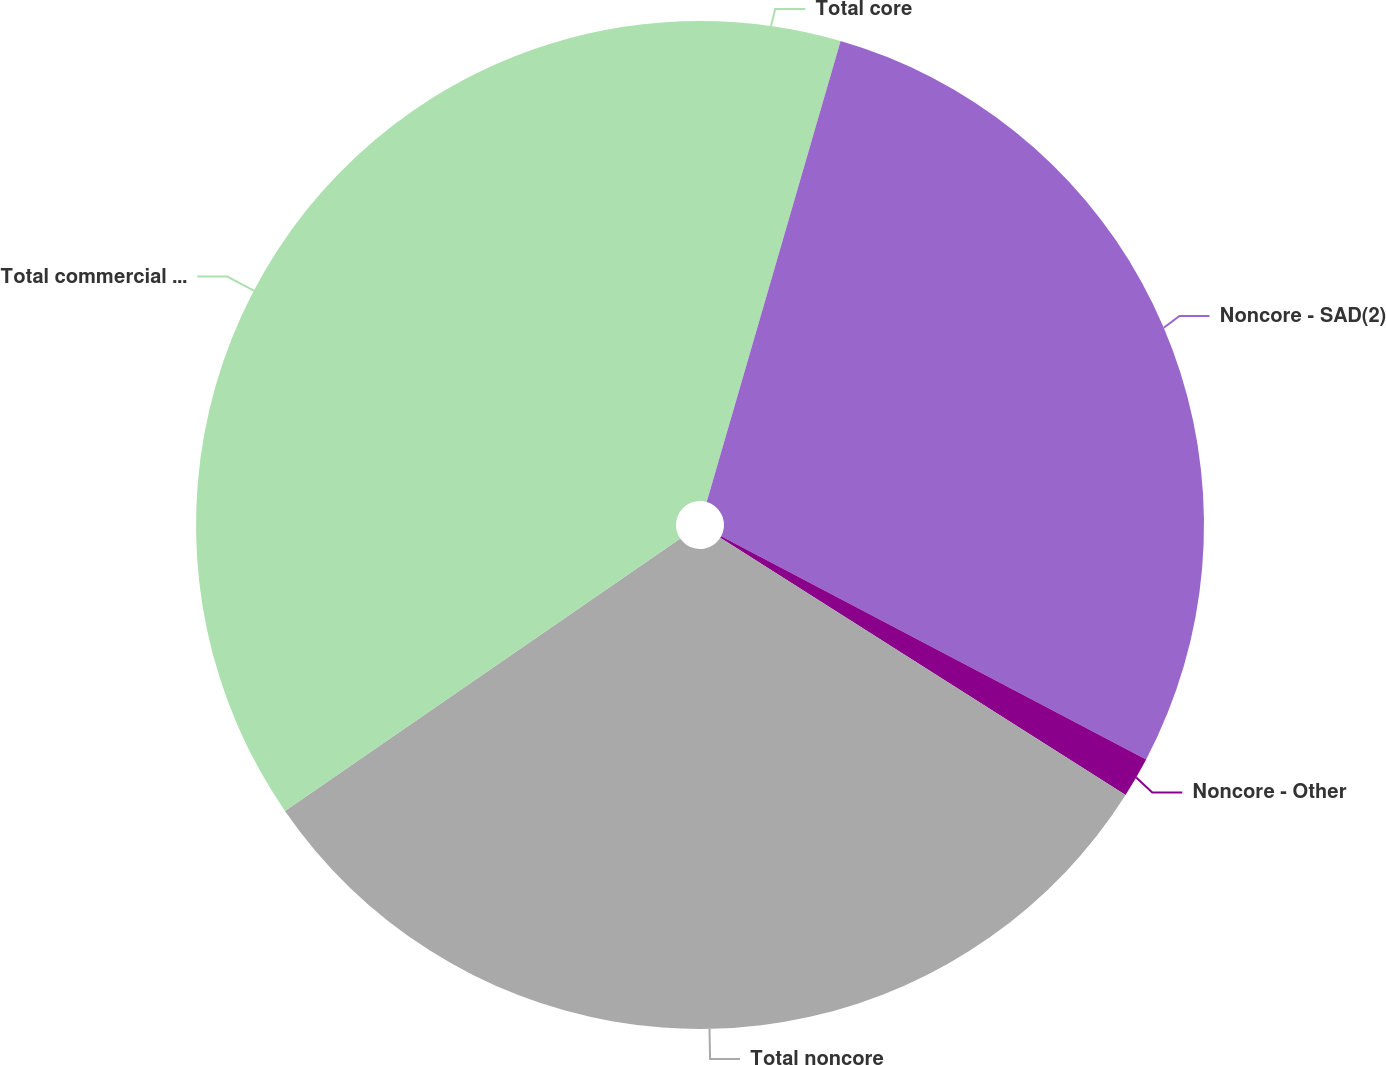Convert chart. <chart><loc_0><loc_0><loc_500><loc_500><pie_chart><fcel>Total core<fcel>Noncore - SAD(2)<fcel>Noncore - Other<fcel>Total noncore<fcel>Total commercial real estate<nl><fcel>4.5%<fcel>28.2%<fcel>1.3%<fcel>31.4%<fcel>34.6%<nl></chart> 